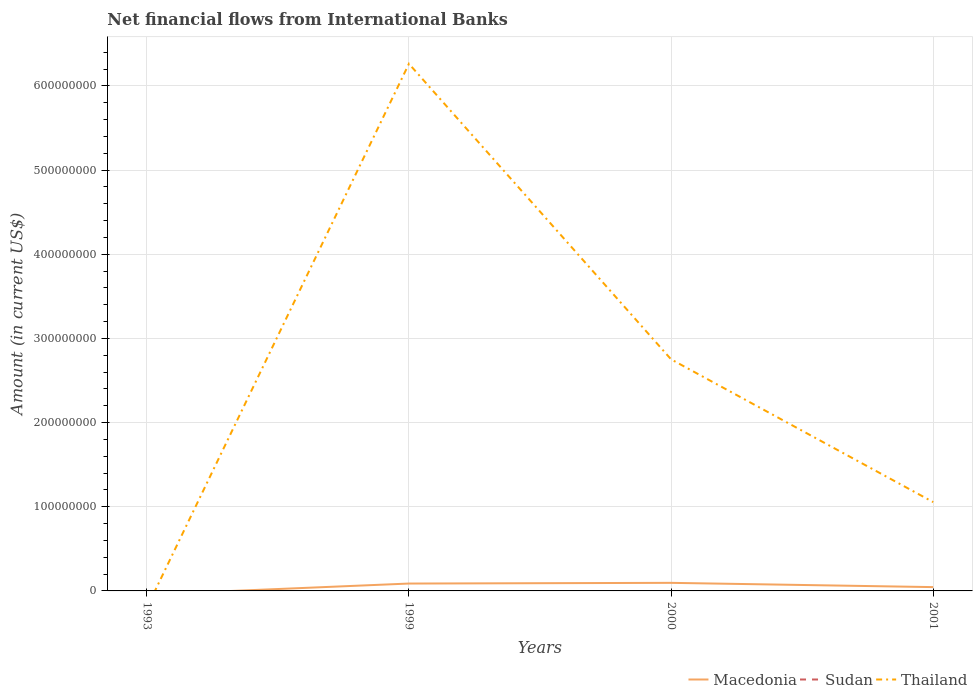How many different coloured lines are there?
Give a very brief answer. 2. Is the number of lines equal to the number of legend labels?
Make the answer very short. No. Across all years, what is the maximum net financial aid flows in Macedonia?
Keep it short and to the point. 0. What is the total net financial aid flows in Macedonia in the graph?
Ensure brevity in your answer.  5.07e+06. What is the difference between the highest and the second highest net financial aid flows in Macedonia?
Make the answer very short. 9.59e+06. What is the difference between the highest and the lowest net financial aid flows in Macedonia?
Keep it short and to the point. 2. What is the difference between two consecutive major ticks on the Y-axis?
Keep it short and to the point. 1.00e+08. What is the title of the graph?
Offer a terse response. Net financial flows from International Banks. What is the label or title of the X-axis?
Make the answer very short. Years. What is the label or title of the Y-axis?
Your answer should be very brief. Amount (in current US$). What is the Amount (in current US$) of Sudan in 1993?
Give a very brief answer. 0. What is the Amount (in current US$) of Thailand in 1993?
Ensure brevity in your answer.  0. What is the Amount (in current US$) of Macedonia in 1999?
Provide a succinct answer. 8.77e+06. What is the Amount (in current US$) of Sudan in 1999?
Your answer should be compact. 0. What is the Amount (in current US$) in Thailand in 1999?
Your answer should be compact. 6.26e+08. What is the Amount (in current US$) of Macedonia in 2000?
Offer a terse response. 9.59e+06. What is the Amount (in current US$) in Thailand in 2000?
Offer a terse response. 2.75e+08. What is the Amount (in current US$) of Macedonia in 2001?
Your answer should be compact. 4.52e+06. What is the Amount (in current US$) in Sudan in 2001?
Ensure brevity in your answer.  0. What is the Amount (in current US$) of Thailand in 2001?
Provide a succinct answer. 1.06e+08. Across all years, what is the maximum Amount (in current US$) of Macedonia?
Offer a very short reply. 9.59e+06. Across all years, what is the maximum Amount (in current US$) of Thailand?
Keep it short and to the point. 6.26e+08. What is the total Amount (in current US$) in Macedonia in the graph?
Keep it short and to the point. 2.29e+07. What is the total Amount (in current US$) in Thailand in the graph?
Give a very brief answer. 1.01e+09. What is the difference between the Amount (in current US$) in Macedonia in 1999 and that in 2000?
Provide a short and direct response. -8.21e+05. What is the difference between the Amount (in current US$) in Thailand in 1999 and that in 2000?
Provide a succinct answer. 3.51e+08. What is the difference between the Amount (in current US$) of Macedonia in 1999 and that in 2001?
Make the answer very short. 4.25e+06. What is the difference between the Amount (in current US$) in Thailand in 1999 and that in 2001?
Your answer should be very brief. 5.21e+08. What is the difference between the Amount (in current US$) of Macedonia in 2000 and that in 2001?
Your answer should be compact. 5.07e+06. What is the difference between the Amount (in current US$) of Thailand in 2000 and that in 2001?
Give a very brief answer. 1.70e+08. What is the difference between the Amount (in current US$) of Macedonia in 1999 and the Amount (in current US$) of Thailand in 2000?
Provide a short and direct response. -2.66e+08. What is the difference between the Amount (in current US$) in Macedonia in 1999 and the Amount (in current US$) in Thailand in 2001?
Offer a very short reply. -9.67e+07. What is the difference between the Amount (in current US$) of Macedonia in 2000 and the Amount (in current US$) of Thailand in 2001?
Your answer should be compact. -9.59e+07. What is the average Amount (in current US$) in Macedonia per year?
Your answer should be very brief. 5.72e+06. What is the average Amount (in current US$) in Sudan per year?
Ensure brevity in your answer.  0. What is the average Amount (in current US$) of Thailand per year?
Keep it short and to the point. 2.52e+08. In the year 1999, what is the difference between the Amount (in current US$) of Macedonia and Amount (in current US$) of Thailand?
Your response must be concise. -6.17e+08. In the year 2000, what is the difference between the Amount (in current US$) of Macedonia and Amount (in current US$) of Thailand?
Give a very brief answer. -2.66e+08. In the year 2001, what is the difference between the Amount (in current US$) of Macedonia and Amount (in current US$) of Thailand?
Your answer should be very brief. -1.01e+08. What is the ratio of the Amount (in current US$) in Macedonia in 1999 to that in 2000?
Keep it short and to the point. 0.91. What is the ratio of the Amount (in current US$) of Thailand in 1999 to that in 2000?
Your answer should be very brief. 2.28. What is the ratio of the Amount (in current US$) in Macedonia in 1999 to that in 2001?
Your response must be concise. 1.94. What is the ratio of the Amount (in current US$) of Thailand in 1999 to that in 2001?
Your answer should be very brief. 5.93. What is the ratio of the Amount (in current US$) of Macedonia in 2000 to that in 2001?
Offer a terse response. 2.12. What is the ratio of the Amount (in current US$) in Thailand in 2000 to that in 2001?
Your answer should be very brief. 2.61. What is the difference between the highest and the second highest Amount (in current US$) in Macedonia?
Offer a very short reply. 8.21e+05. What is the difference between the highest and the second highest Amount (in current US$) of Thailand?
Keep it short and to the point. 3.51e+08. What is the difference between the highest and the lowest Amount (in current US$) of Macedonia?
Your answer should be compact. 9.59e+06. What is the difference between the highest and the lowest Amount (in current US$) of Thailand?
Offer a terse response. 6.26e+08. 